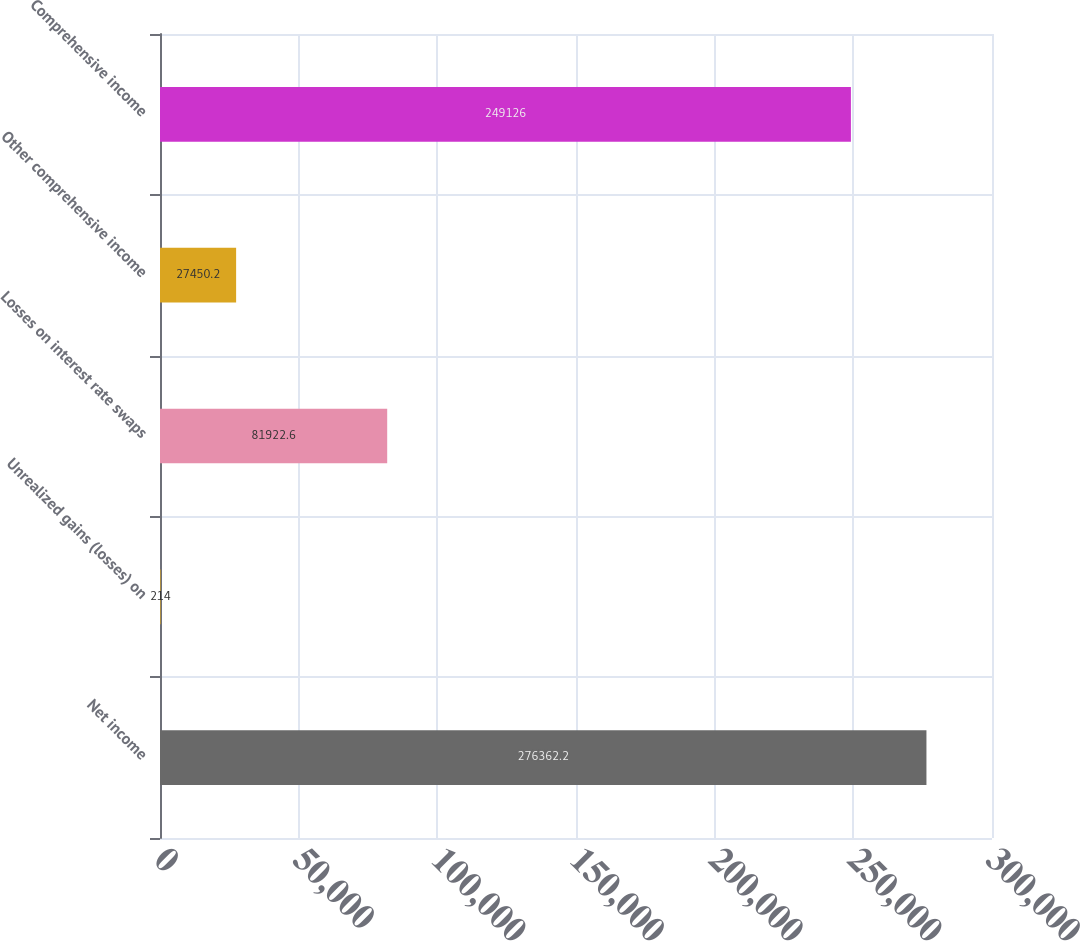Convert chart to OTSL. <chart><loc_0><loc_0><loc_500><loc_500><bar_chart><fcel>Net income<fcel>Unrealized gains (losses) on<fcel>Losses on interest rate swaps<fcel>Other comprehensive income<fcel>Comprehensive income<nl><fcel>276362<fcel>214<fcel>81922.6<fcel>27450.2<fcel>249126<nl></chart> 